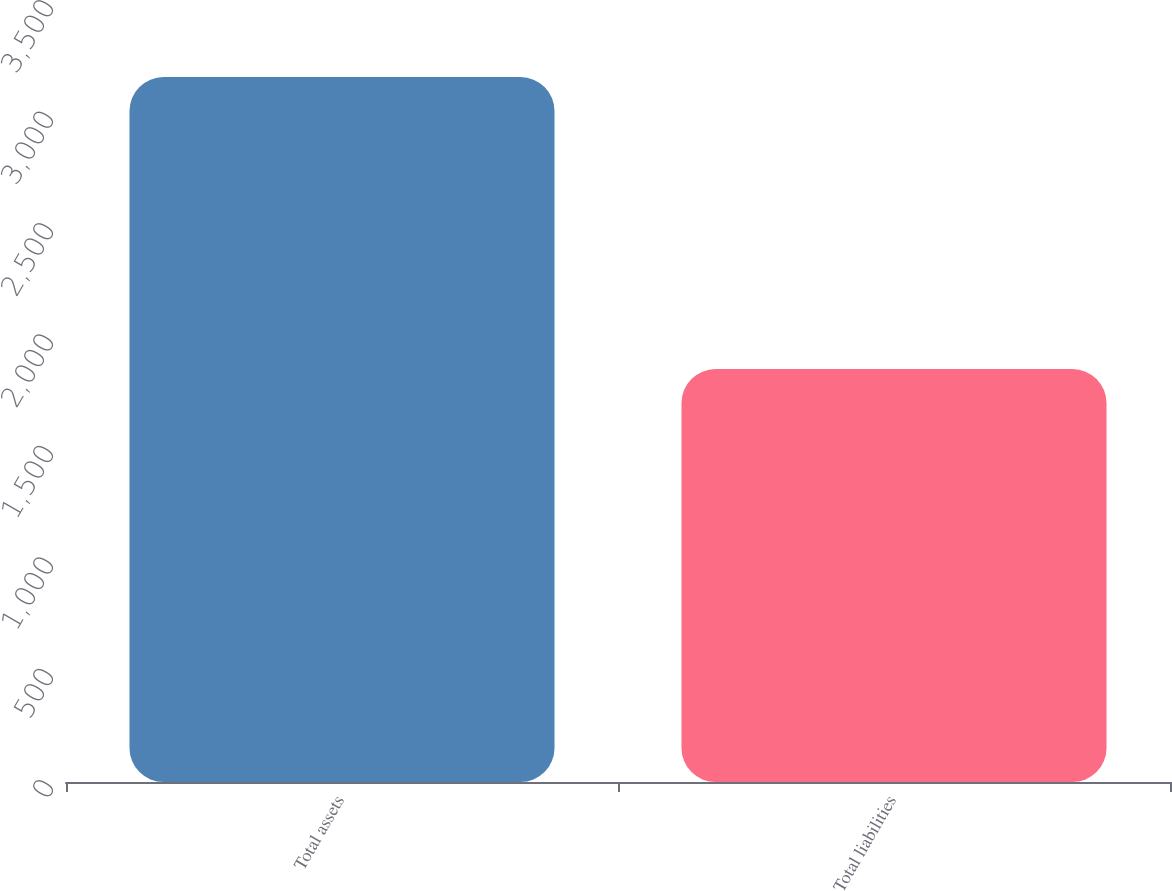Convert chart. <chart><loc_0><loc_0><loc_500><loc_500><bar_chart><fcel>Total assets<fcel>Total liabilities<nl><fcel>3163<fcel>1853<nl></chart> 